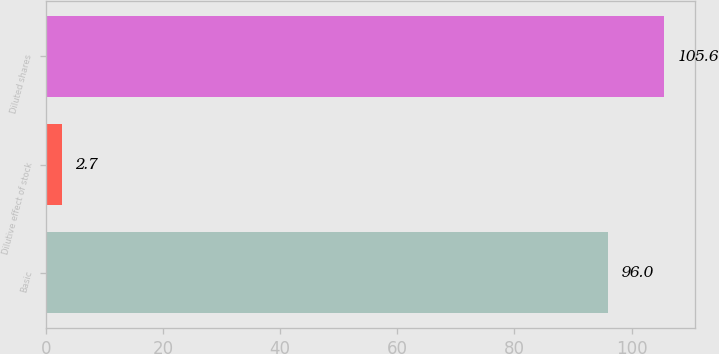Convert chart to OTSL. <chart><loc_0><loc_0><loc_500><loc_500><bar_chart><fcel>Basic<fcel>Dilutive effect of stock<fcel>Diluted shares<nl><fcel>96<fcel>2.7<fcel>105.6<nl></chart> 